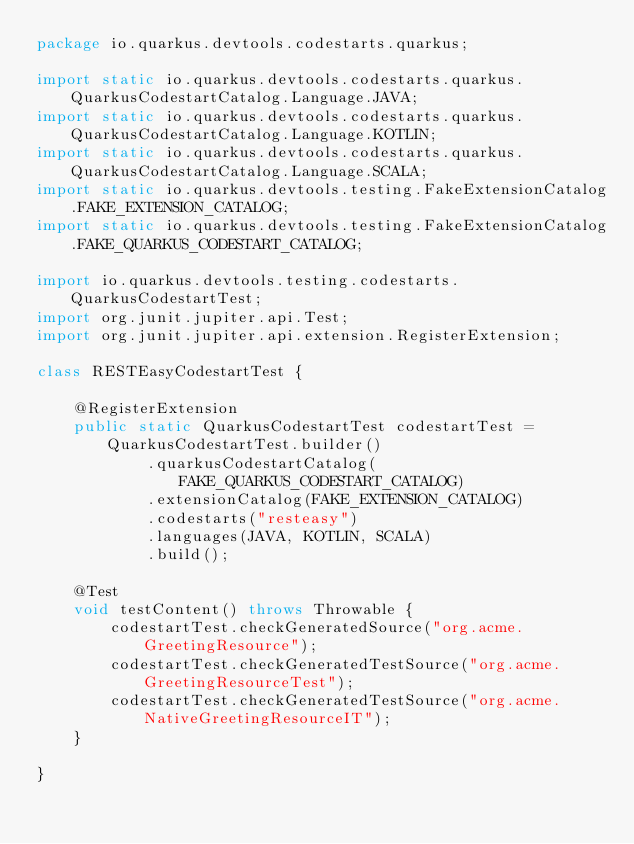<code> <loc_0><loc_0><loc_500><loc_500><_Java_>package io.quarkus.devtools.codestarts.quarkus;

import static io.quarkus.devtools.codestarts.quarkus.QuarkusCodestartCatalog.Language.JAVA;
import static io.quarkus.devtools.codestarts.quarkus.QuarkusCodestartCatalog.Language.KOTLIN;
import static io.quarkus.devtools.codestarts.quarkus.QuarkusCodestartCatalog.Language.SCALA;
import static io.quarkus.devtools.testing.FakeExtensionCatalog.FAKE_EXTENSION_CATALOG;
import static io.quarkus.devtools.testing.FakeExtensionCatalog.FAKE_QUARKUS_CODESTART_CATALOG;

import io.quarkus.devtools.testing.codestarts.QuarkusCodestartTest;
import org.junit.jupiter.api.Test;
import org.junit.jupiter.api.extension.RegisterExtension;

class RESTEasyCodestartTest {

    @RegisterExtension
    public static QuarkusCodestartTest codestartTest = QuarkusCodestartTest.builder()
            .quarkusCodestartCatalog(FAKE_QUARKUS_CODESTART_CATALOG)
            .extensionCatalog(FAKE_EXTENSION_CATALOG)
            .codestarts("resteasy")
            .languages(JAVA, KOTLIN, SCALA)
            .build();

    @Test
    void testContent() throws Throwable {
        codestartTest.checkGeneratedSource("org.acme.GreetingResource");
        codestartTest.checkGeneratedTestSource("org.acme.GreetingResourceTest");
        codestartTest.checkGeneratedTestSource("org.acme.NativeGreetingResourceIT");
    }

}
</code> 